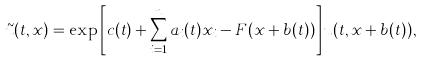Convert formula to latex. <formula><loc_0><loc_0><loc_500><loc_500>\tilde { u } ( t , x ) = \exp \left [ c ( t ) + \sum _ { i = 1 } ^ { n } a _ { i } ( t ) x _ { i } - F ( x + b ( t ) ) \right ] u ( t , x + b ( t ) ) ,</formula> 